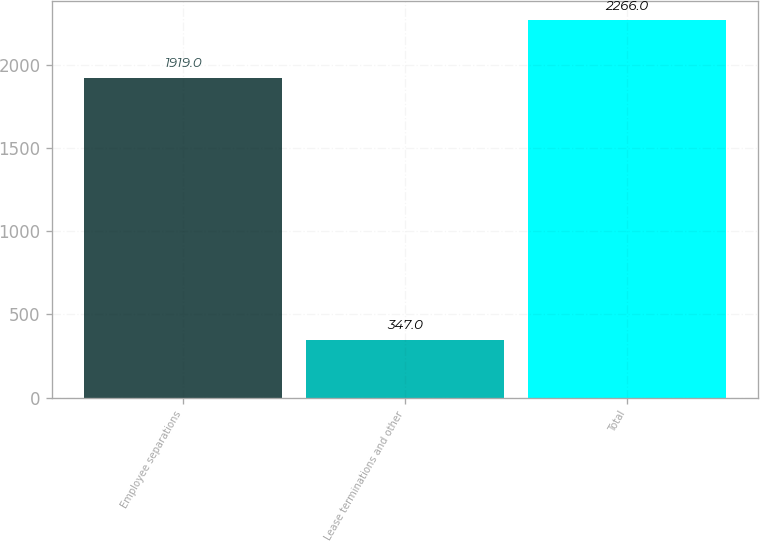Convert chart to OTSL. <chart><loc_0><loc_0><loc_500><loc_500><bar_chart><fcel>Employee separations<fcel>Lease terminations and other<fcel>Total<nl><fcel>1919<fcel>347<fcel>2266<nl></chart> 